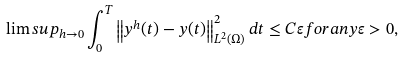<formula> <loc_0><loc_0><loc_500><loc_500>\lim s u p _ { h \rightarrow 0 } \int _ { 0 } ^ { T } \left \| y ^ { h } ( t ) - y ( t ) \right \| _ { L ^ { 2 } ( \Omega ) } ^ { 2 } d t \leq C \varepsilon f o r a n y \varepsilon > 0 ,</formula> 